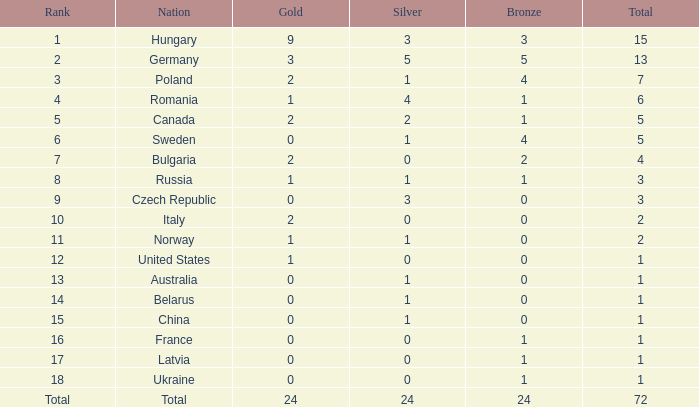Considering 0 gold and a rank of 6, what is the average total? 5.0. Can you give me this table as a dict? {'header': ['Rank', 'Nation', 'Gold', 'Silver', 'Bronze', 'Total'], 'rows': [['1', 'Hungary', '9', '3', '3', '15'], ['2', 'Germany', '3', '5', '5', '13'], ['3', 'Poland', '2', '1', '4', '7'], ['4', 'Romania', '1', '4', '1', '6'], ['5', 'Canada', '2', '2', '1', '5'], ['6', 'Sweden', '0', '1', '4', '5'], ['7', 'Bulgaria', '2', '0', '2', '4'], ['8', 'Russia', '1', '1', '1', '3'], ['9', 'Czech Republic', '0', '3', '0', '3'], ['10', 'Italy', '2', '0', '0', '2'], ['11', 'Norway', '1', '1', '0', '2'], ['12', 'United States', '1', '0', '0', '1'], ['13', 'Australia', '0', '1', '0', '1'], ['14', 'Belarus', '0', '1', '0', '1'], ['15', 'China', '0', '1', '0', '1'], ['16', 'France', '0', '0', '1', '1'], ['17', 'Latvia', '0', '0', '1', '1'], ['18', 'Ukraine', '0', '0', '1', '1'], ['Total', 'Total', '24', '24', '24', '72']]} 